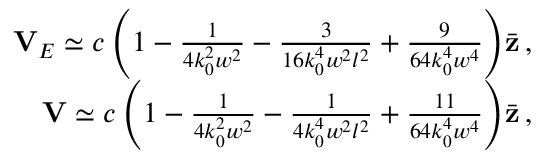<formula> <loc_0><loc_0><loc_500><loc_500>\begin{array} { r } { { V } _ { E } \simeq c \left ( 1 - \frac { 1 } { 4 k _ { 0 } ^ { 2 } w ^ { 2 } } - \frac { 3 } { 1 6 k _ { 0 } ^ { 4 } w ^ { 2 } l ^ { 2 } } + \frac { 9 } { 6 4 k _ { 0 } ^ { 4 } w ^ { 4 } } \right ) \, \bar { z } \, , } \\ { { V } \simeq c \left ( 1 - \frac { 1 } { 4 k _ { 0 } ^ { 2 } w ^ { 2 } } - \frac { 1 } { 4 k _ { 0 } ^ { 4 } w ^ { 2 } l ^ { 2 } } + \frac { 1 1 } { 6 4 k _ { 0 } ^ { 4 } w ^ { 4 } } \right ) \, \bar { z } \, , } \end{array}</formula> 